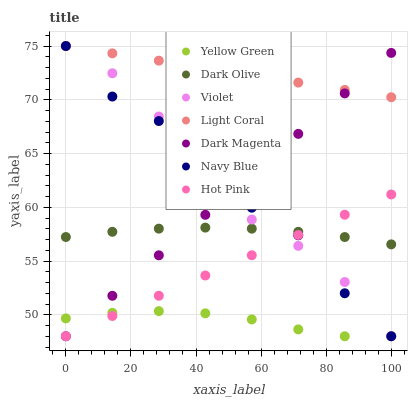Does Yellow Green have the minimum area under the curve?
Answer yes or no. Yes. Does Light Coral have the maximum area under the curve?
Answer yes or no. Yes. Does Navy Blue have the minimum area under the curve?
Answer yes or no. No. Does Navy Blue have the maximum area under the curve?
Answer yes or no. No. Is Hot Pink the smoothest?
Answer yes or no. Yes. Is Navy Blue the roughest?
Answer yes or no. Yes. Is Yellow Green the smoothest?
Answer yes or no. No. Is Yellow Green the roughest?
Answer yes or no. No. Does Hot Pink have the lowest value?
Answer yes or no. Yes. Does Dark Olive have the lowest value?
Answer yes or no. No. Does Violet have the highest value?
Answer yes or no. Yes. Does Yellow Green have the highest value?
Answer yes or no. No. Is Hot Pink less than Light Coral?
Answer yes or no. Yes. Is Light Coral greater than Hot Pink?
Answer yes or no. Yes. Does Dark Magenta intersect Navy Blue?
Answer yes or no. Yes. Is Dark Magenta less than Navy Blue?
Answer yes or no. No. Is Dark Magenta greater than Navy Blue?
Answer yes or no. No. Does Hot Pink intersect Light Coral?
Answer yes or no. No. 